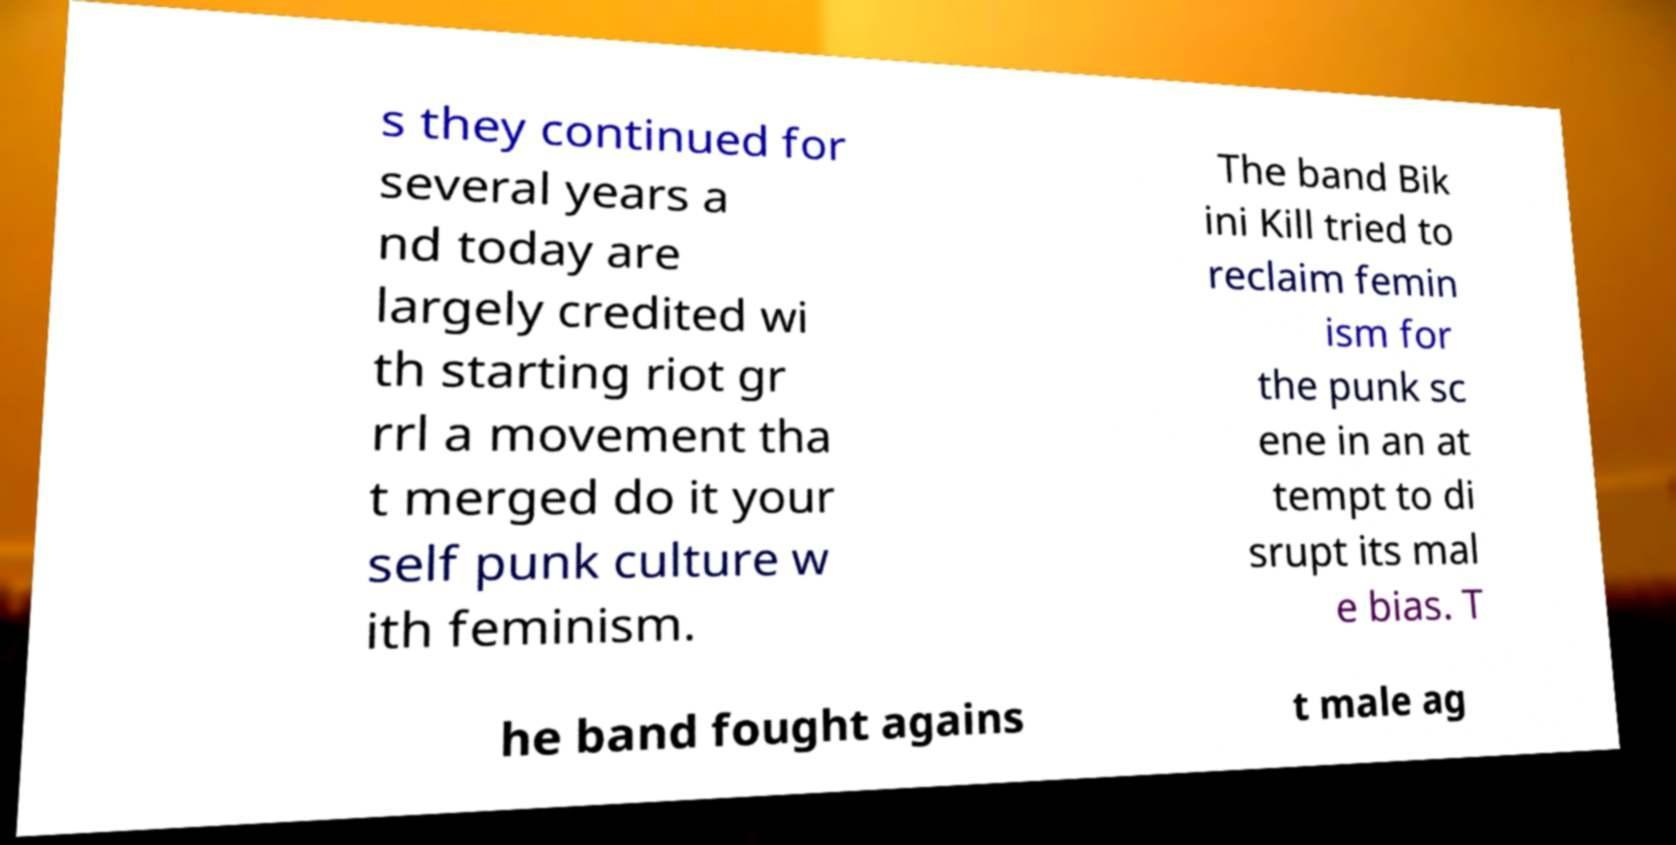What messages or text are displayed in this image? I need them in a readable, typed format. s they continued for several years a nd today are largely credited wi th starting riot gr rrl a movement tha t merged do it your self punk culture w ith feminism. The band Bik ini Kill tried to reclaim femin ism for the punk sc ene in an at tempt to di srupt its mal e bias. T he band fought agains t male ag 